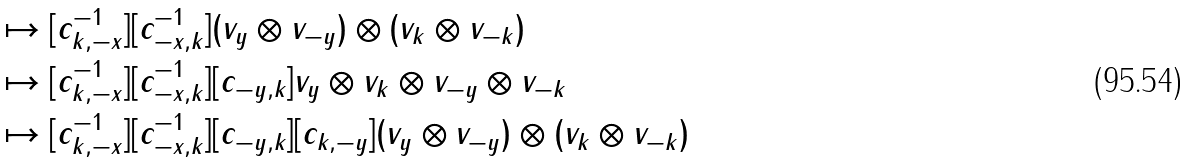<formula> <loc_0><loc_0><loc_500><loc_500>& \mapsto [ c ^ { - 1 } _ { k , - x } ] [ c ^ { - 1 } _ { - x , k } ] ( v _ { y } \otimes v _ { - y } ) \otimes ( v _ { k } \otimes v _ { - k } ) \\ & \mapsto [ c ^ { - 1 } _ { k , - x } ] [ c ^ { - 1 } _ { - x , k } ] [ c _ { - y , k } ] v _ { y } \otimes v _ { k } \otimes v _ { - y } \otimes v _ { - k } \\ & \mapsto [ c ^ { - 1 } _ { k , - x } ] [ c ^ { - 1 } _ { - x , k } ] [ c _ { - y , k } ] [ c _ { k , - y } ] ( v _ { y } \otimes v _ { - y } ) \otimes ( v _ { k } \otimes v _ { - k } )</formula> 